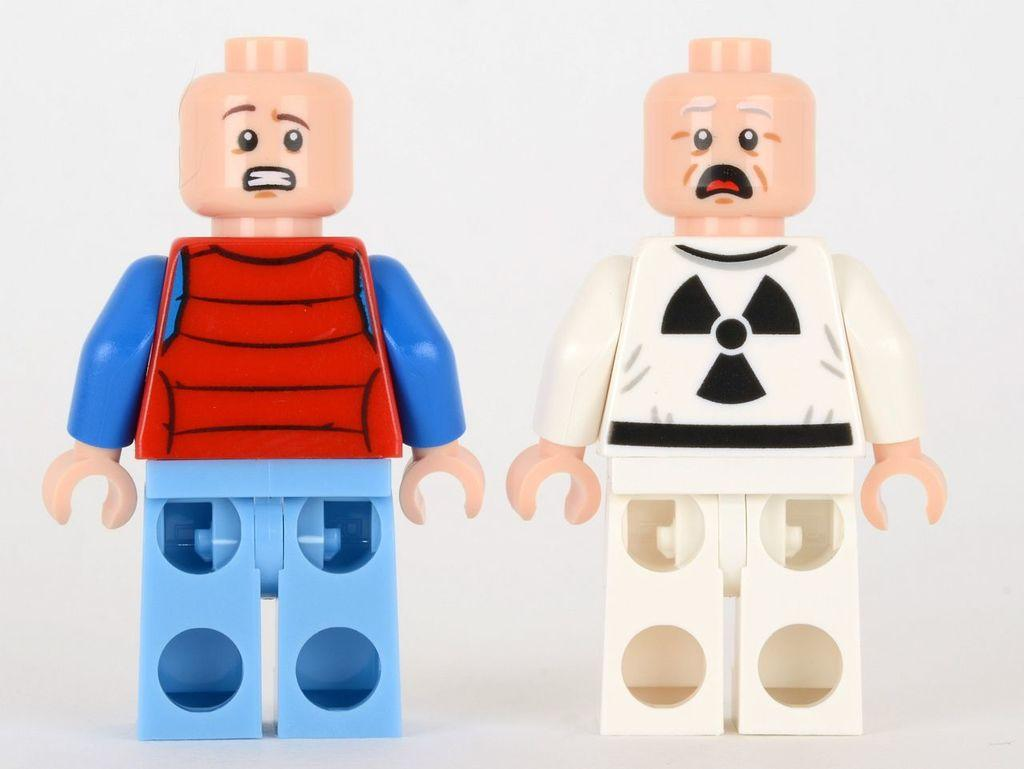How many toys can be seen in the image? There are two toys in the image. What can be observed about the background of the image? The background of the image is white. What type of nerve is responsible for the toys' movement in the image? There are no moving toys in the image, so there is no nerve responsible for their movement. 